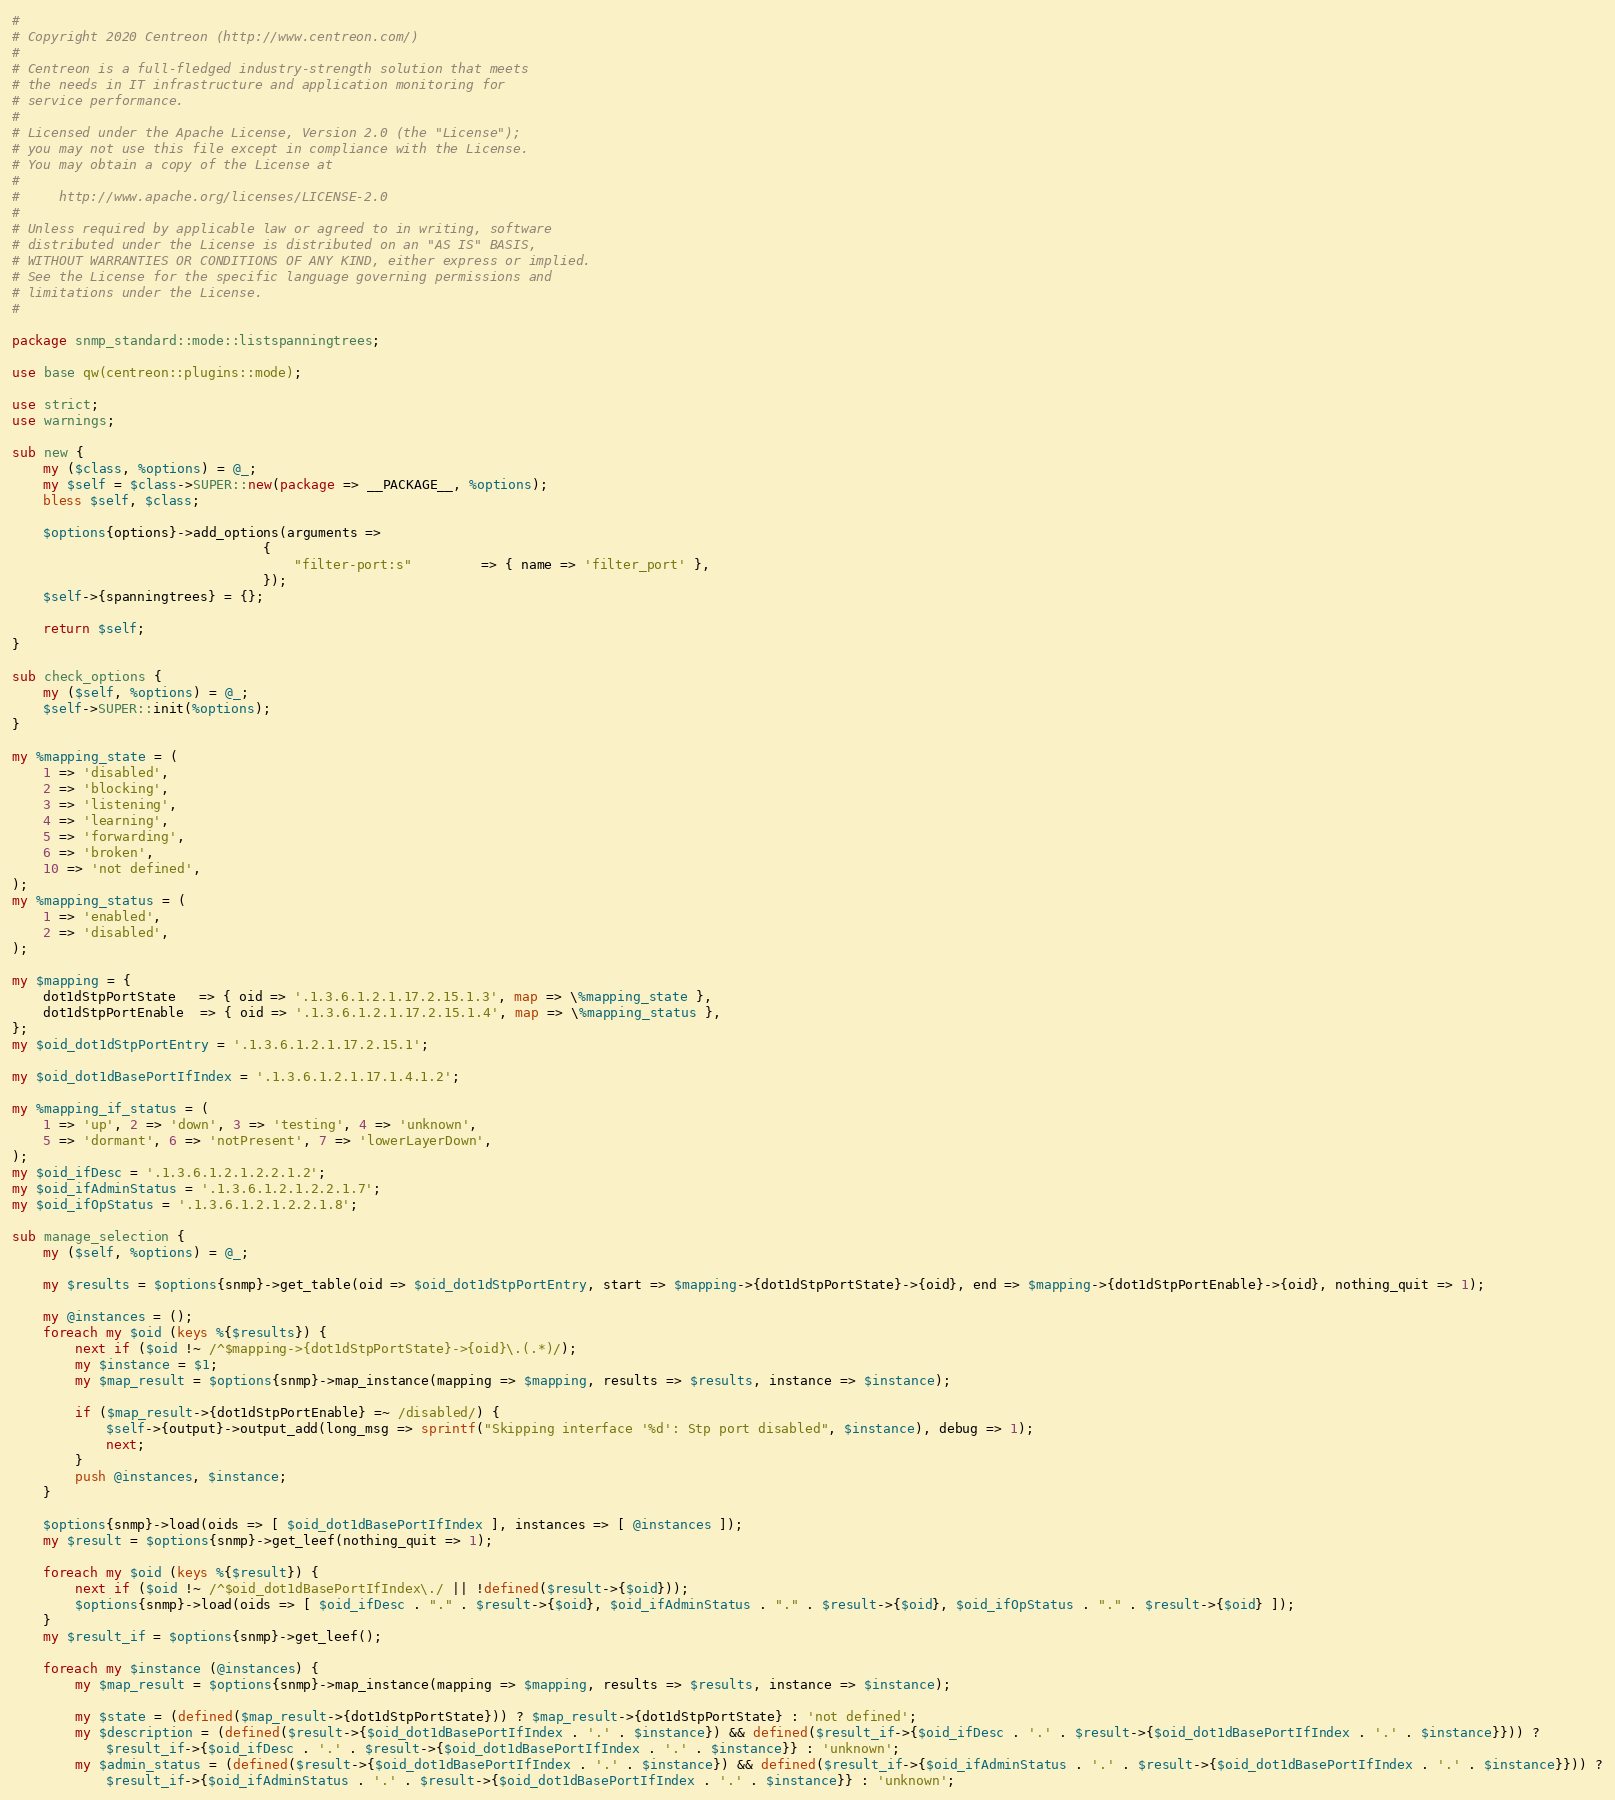<code> <loc_0><loc_0><loc_500><loc_500><_Perl_>#
# Copyright 2020 Centreon (http://www.centreon.com/)
#
# Centreon is a full-fledged industry-strength solution that meets
# the needs in IT infrastructure and application monitoring for
# service performance.
#
# Licensed under the Apache License, Version 2.0 (the "License");
# you may not use this file except in compliance with the License.
# You may obtain a copy of the License at
#
#     http://www.apache.org/licenses/LICENSE-2.0
#
# Unless required by applicable law or agreed to in writing, software
# distributed under the License is distributed on an "AS IS" BASIS,
# WITHOUT WARRANTIES OR CONDITIONS OF ANY KIND, either express or implied.
# See the License for the specific language governing permissions and
# limitations under the License.
#

package snmp_standard::mode::listspanningtrees;

use base qw(centreon::plugins::mode);

use strict;
use warnings;

sub new {
    my ($class, %options) = @_;
    my $self = $class->SUPER::new(package => __PACKAGE__, %options);
    bless $self, $class;
    
    $options{options}->add_options(arguments =>
                                {
                                    "filter-port:s"         => { name => 'filter_port' },
                                });
    $self->{spanningtrees} = {};

    return $self;
}

sub check_options {
    my ($self, %options) = @_;
    $self->SUPER::init(%options);
}

my %mapping_state = (
    1 => 'disabled',
    2 => 'blocking',
    3 => 'listening',
    4 => 'learning',
    5 => 'forwarding',
    6 => 'broken',
    10 => 'not defined',
);
my %mapping_status = (
    1 => 'enabled',
    2 => 'disabled',
);

my $mapping = {
    dot1dStpPortState   => { oid => '.1.3.6.1.2.1.17.2.15.1.3', map => \%mapping_state },
    dot1dStpPortEnable  => { oid => '.1.3.6.1.2.1.17.2.15.1.4', map => \%mapping_status },
};
my $oid_dot1dStpPortEntry = '.1.3.6.1.2.1.17.2.15.1';

my $oid_dot1dBasePortIfIndex = '.1.3.6.1.2.1.17.1.4.1.2';

my %mapping_if_status = (
    1 => 'up', 2 => 'down', 3 => 'testing', 4 => 'unknown',
    5 => 'dormant', 6 => 'notPresent', 7 => 'lowerLayerDown',
);
my $oid_ifDesc = '.1.3.6.1.2.1.2.2.1.2';
my $oid_ifAdminStatus = '.1.3.6.1.2.1.2.2.1.7';
my $oid_ifOpStatus = '.1.3.6.1.2.1.2.2.1.8';

sub manage_selection {
    my ($self, %options) = @_;

    my $results = $options{snmp}->get_table(oid => $oid_dot1dStpPortEntry, start => $mapping->{dot1dStpPortState}->{oid}, end => $mapping->{dot1dStpPortEnable}->{oid}, nothing_quit => 1);

    my @instances = ();
    foreach my $oid (keys %{$results}) {
        next if ($oid !~ /^$mapping->{dot1dStpPortState}->{oid}\.(.*)/);
        my $instance = $1;
        my $map_result = $options{snmp}->map_instance(mapping => $mapping, results => $results, instance => $instance);

        if ($map_result->{dot1dStpPortEnable} =~ /disabled/) {
            $self->{output}->output_add(long_msg => sprintf("Skipping interface '%d': Stp port disabled", $instance), debug => 1);
            next;
        }
        push @instances, $instance;
    }

    $options{snmp}->load(oids => [ $oid_dot1dBasePortIfIndex ], instances => [ @instances ]);
    my $result = $options{snmp}->get_leef(nothing_quit => 1);

    foreach my $oid (keys %{$result}) {
        next if ($oid !~ /^$oid_dot1dBasePortIfIndex\./ || !defined($result->{$oid}));
        $options{snmp}->load(oids => [ $oid_ifDesc . "." . $result->{$oid}, $oid_ifAdminStatus . "." . $result->{$oid}, $oid_ifOpStatus . "." . $result->{$oid} ]);
    }
    my $result_if = $options{snmp}->get_leef();

    foreach my $instance (@instances) {
        my $map_result = $options{snmp}->map_instance(mapping => $mapping, results => $results, instance => $instance);

        my $state = (defined($map_result->{dot1dStpPortState})) ? $map_result->{dot1dStpPortState} : 'not defined';
        my $description = (defined($result->{$oid_dot1dBasePortIfIndex . '.' . $instance}) && defined($result_if->{$oid_ifDesc . '.' . $result->{$oid_dot1dBasePortIfIndex . '.' . $instance}})) ?
            $result_if->{$oid_ifDesc . '.' . $result->{$oid_dot1dBasePortIfIndex . '.' . $instance}} : 'unknown';
        my $admin_status = (defined($result->{$oid_dot1dBasePortIfIndex . '.' . $instance}) && defined($result_if->{$oid_ifAdminStatus . '.' . $result->{$oid_dot1dBasePortIfIndex . '.' . $instance}})) ?
            $result_if->{$oid_ifAdminStatus . '.' . $result->{$oid_dot1dBasePortIfIndex . '.' . $instance}} : 'unknown';</code> 